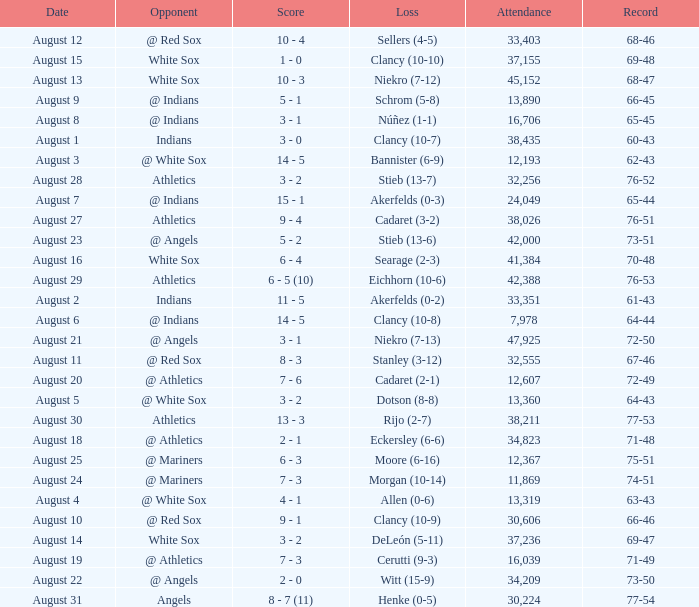What was the attendance when the record was 77-54? 30224.0. 